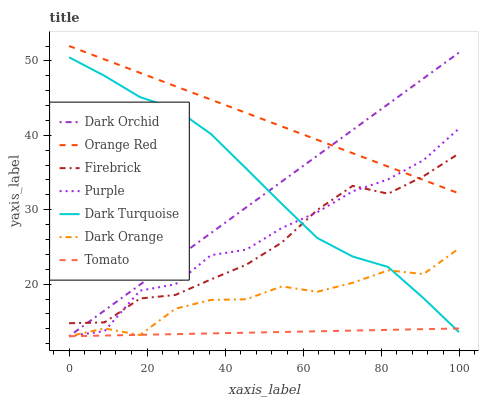Does Dark Orange have the minimum area under the curve?
Answer yes or no. No. Does Dark Orange have the maximum area under the curve?
Answer yes or no. No. Is Dark Orange the smoothest?
Answer yes or no. No. Is Dark Orange the roughest?
Answer yes or no. No. Does Dark Turquoise have the lowest value?
Answer yes or no. No. Does Dark Orange have the highest value?
Answer yes or no. No. Is Tomato less than Orange Red?
Answer yes or no. Yes. Is Orange Red greater than Dark Orange?
Answer yes or no. Yes. Does Tomato intersect Orange Red?
Answer yes or no. No. 